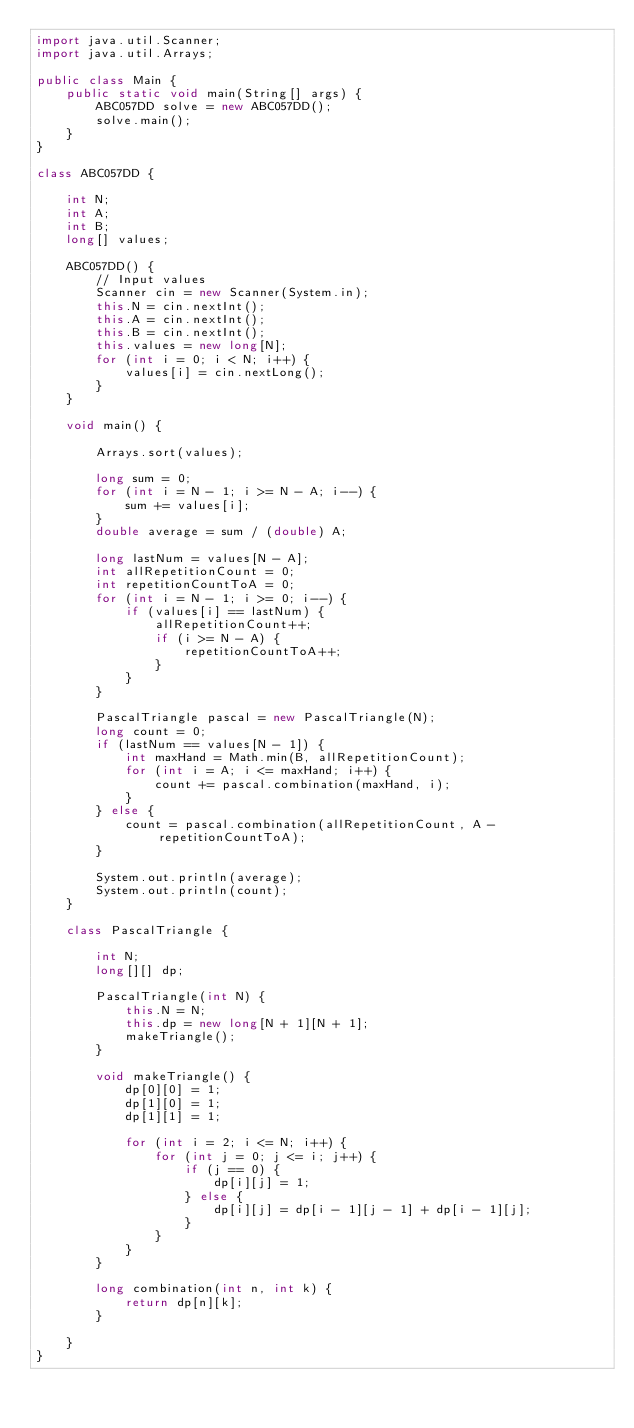Convert code to text. <code><loc_0><loc_0><loc_500><loc_500><_Java_>import java.util.Scanner;
import java.util.Arrays;

public class Main {
	public static void main(String[] args) {
		ABC057DD solve = new ABC057DD();
		solve.main();
	}
}

class ABC057DD {
	
	int N;
	int A;
	int B;
	long[] values;
	
	ABC057DD() {
		// Input values
		Scanner cin = new Scanner(System.in);
		this.N = cin.nextInt();
		this.A = cin.nextInt();
		this.B = cin.nextInt();
		this.values = new long[N];
		for (int i = 0; i < N; i++) {
			values[i] = cin.nextLong();
		}
	}
	
	void main() {
	
		Arrays.sort(values);
		
		long sum = 0;
		for (int i = N - 1; i >= N - A; i--) {
			sum += values[i];
		}
		double average = sum / (double) A;
		
		long lastNum = values[N - A];
		int allRepetitionCount = 0;
		int repetitionCountToA = 0;
		for (int i = N - 1; i >= 0; i--) {
			if (values[i] == lastNum) {
				allRepetitionCount++;
				if (i >= N - A) {
					repetitionCountToA++;
				}
			}
		}
		
		PascalTriangle pascal = new PascalTriangle(N);
		long count = 0;
		if (lastNum == values[N - 1]) {
			int maxHand = Math.min(B, allRepetitionCount);
			for (int i = A; i <= maxHand; i++) {
				count += pascal.combination(maxHand, i);
			}
		} else {
			count = pascal.combination(allRepetitionCount, A - repetitionCountToA);
		}
		
		System.out.println(average);
		System.out.println(count);
	}
	
	class PascalTriangle {
		
		int N;
		long[][] dp;
		
		PascalTriangle(int N) {
			this.N = N;
			this.dp = new long[N + 1][N + 1];
			makeTriangle();
		}
		
		void makeTriangle() {
			dp[0][0] = 1;
			dp[1][0] = 1;
			dp[1][1] = 1;
			
			for (int i = 2; i <= N; i++) {
				for (int j = 0; j <= i; j++) {
					if (j == 0) {
						dp[i][j] = 1;
					} else {
						dp[i][j] = dp[i - 1][j - 1] + dp[i - 1][j];
					}					
				}
			}
		}
		
		long combination(int n, int k) {
			return dp[n][k];
		}
		
	}
}</code> 